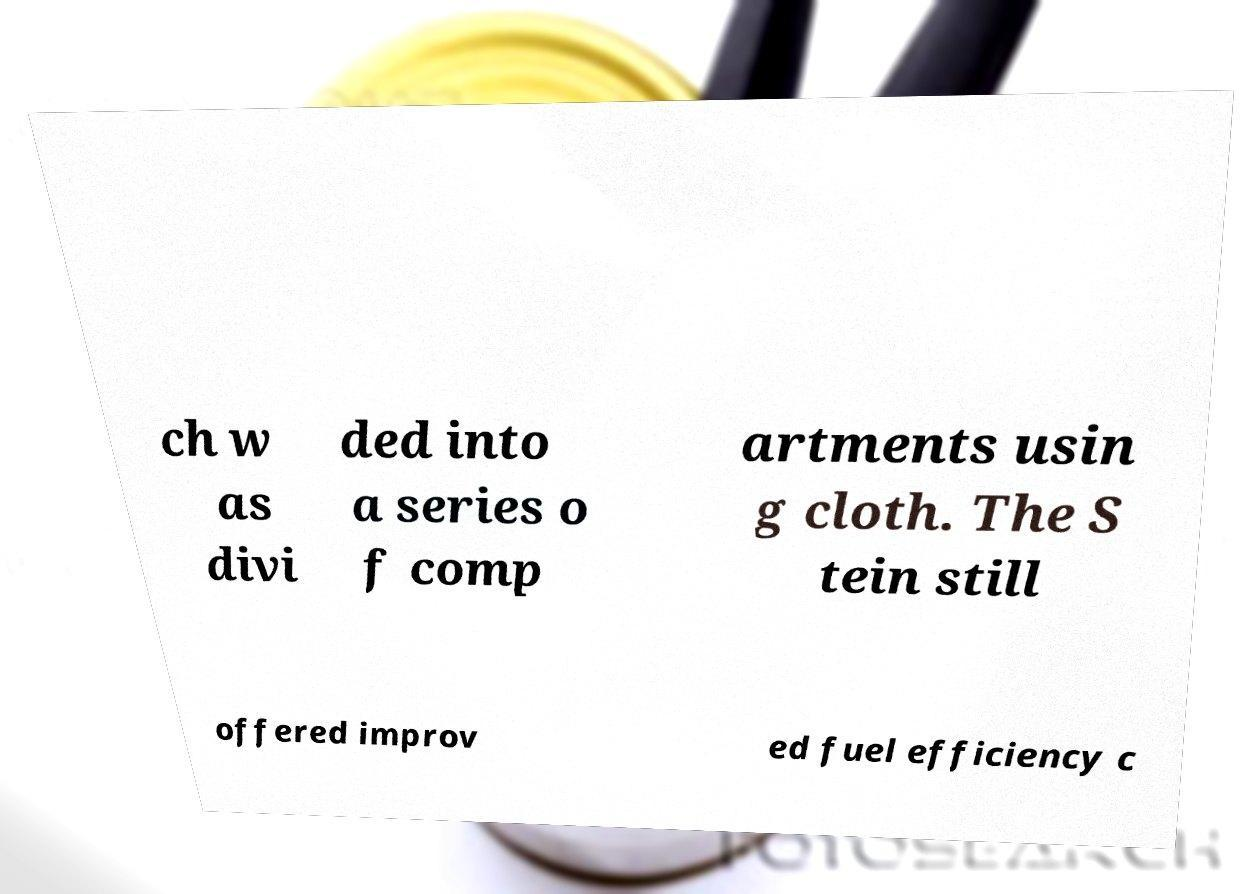Could you assist in decoding the text presented in this image and type it out clearly? ch w as divi ded into a series o f comp artments usin g cloth. The S tein still offered improv ed fuel efficiency c 